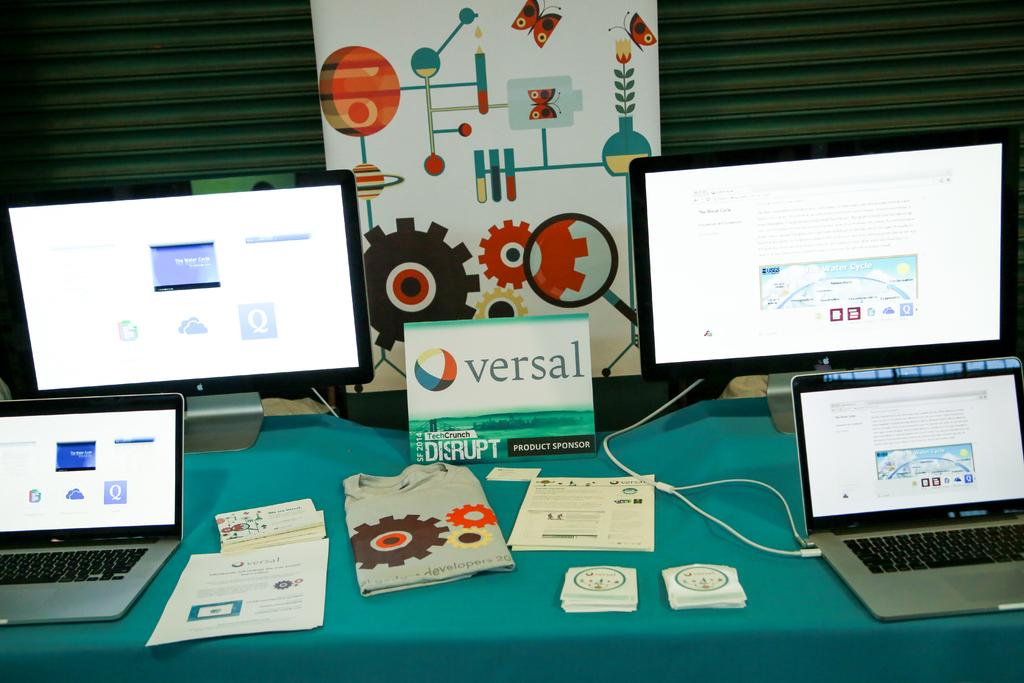<image>
Provide a brief description of the given image. A table full of tech products from the sponsor versal. 